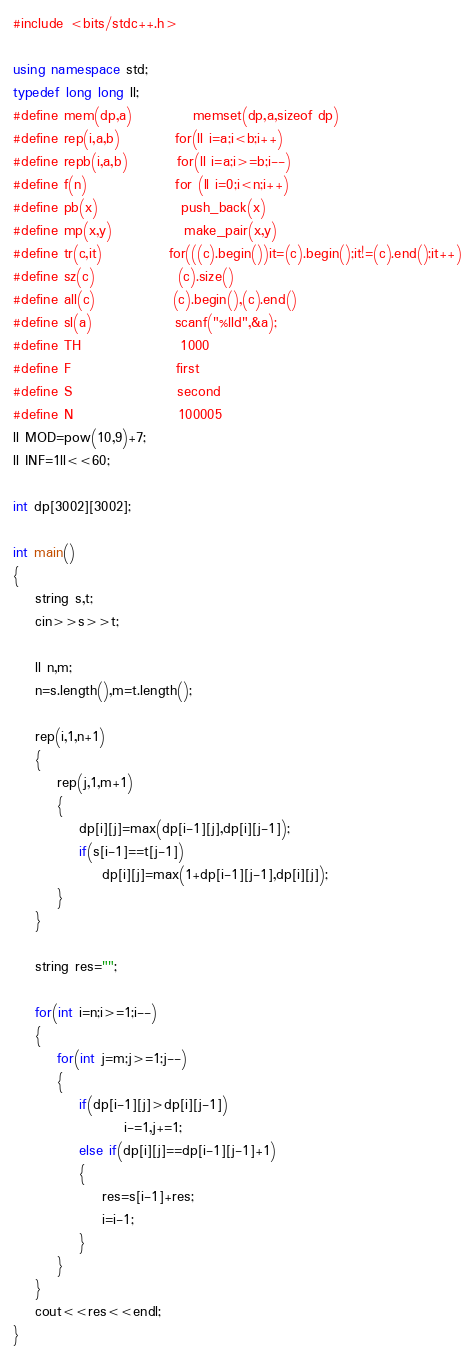Convert code to text. <code><loc_0><loc_0><loc_500><loc_500><_C++_>#include <bits/stdc++.h>

using namespace std;
typedef long long ll;
#define mem(dp,a)           memset(dp,a,sizeof dp)
#define rep(i,a,b)          for(ll i=a;i<b;i++)
#define repb(i,a,b)         for(ll i=a;i>=b;i--)
#define f(n)                for (ll i=0;i<n;i++)
#define pb(x)               push_back(x)
#define mp(x,y)             make_pair(x,y)
#define tr(c,it)            for(((c).begin())it=(c).begin();it!=(c).end();it++)
#define sz(c)               (c).size()
#define all(c)              (c).begin(),(c).end()
#define sl(a)               scanf("%lld",&a);
#define TH                  1000
#define F                   first
#define S                   second
#define N                   100005
ll MOD=pow(10,9)+7;
ll INF=1ll<<60;

int dp[3002][3002];

int main()
{
    string s,t;
    cin>>s>>t;

    ll n,m;
    n=s.length(),m=t.length();

    rep(i,1,n+1)
    {
        rep(j,1,m+1)
        {
            dp[i][j]=max(dp[i-1][j],dp[i][j-1]);
            if(s[i-1]==t[j-1])
                dp[i][j]=max(1+dp[i-1][j-1],dp[i][j]);
        }
    }

    string res="";

    for(int i=n;i>=1;i--)
    {
        for(int j=m;j>=1;j--)
        {
            if(dp[i-1][j]>dp[i][j-1])
                    i-=1,j+=1;
            else if(dp[i][j]==dp[i-1][j-1]+1)
            {
                res=s[i-1]+res;
                i=i-1;
            }
        }
    }
    cout<<res<<endl;
}</code> 